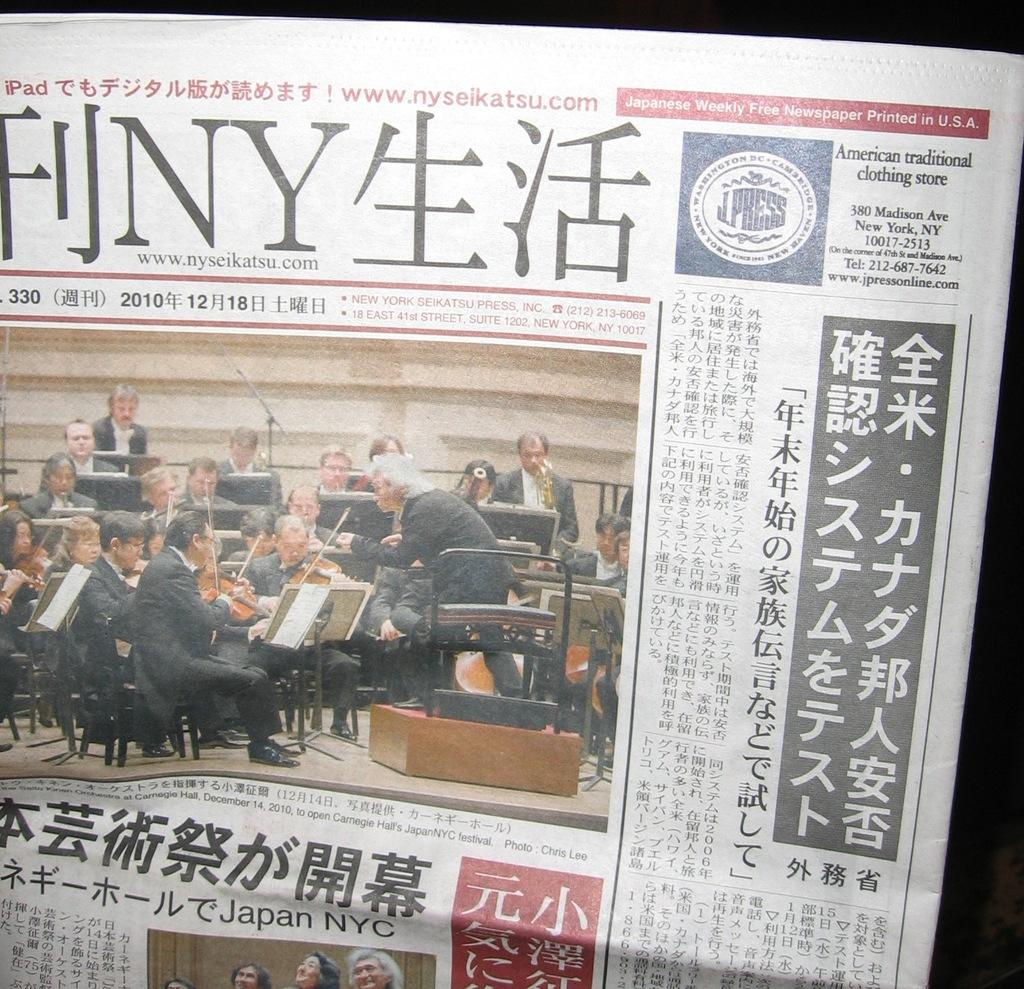<image>
Summarize the visual content of the image. A Japanese newspaper that is printed in the U.S.A. showing an orchestra on front page. 